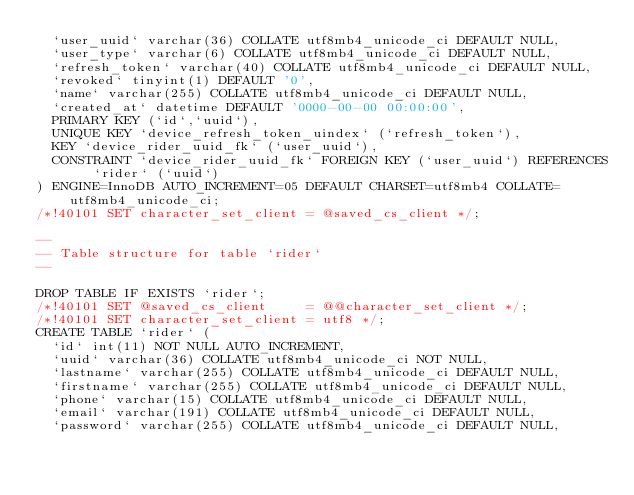Convert code to text. <code><loc_0><loc_0><loc_500><loc_500><_SQL_>  `user_uuid` varchar(36) COLLATE utf8mb4_unicode_ci DEFAULT NULL,
  `user_type` varchar(6) COLLATE utf8mb4_unicode_ci DEFAULT NULL,
  `refresh_token` varchar(40) COLLATE utf8mb4_unicode_ci DEFAULT NULL,
  `revoked` tinyint(1) DEFAULT '0',
  `name` varchar(255) COLLATE utf8mb4_unicode_ci DEFAULT NULL,
  `created_at` datetime DEFAULT '0000-00-00 00:00:00',
  PRIMARY KEY (`id`,`uuid`),
  UNIQUE KEY `device_refresh_token_uindex` (`refresh_token`),
  KEY `device_rider_uuid_fk` (`user_uuid`),
  CONSTRAINT `device_rider_uuid_fk` FOREIGN KEY (`user_uuid`) REFERENCES `rider` (`uuid`)
) ENGINE=InnoDB AUTO_INCREMENT=05 DEFAULT CHARSET=utf8mb4 COLLATE=utf8mb4_unicode_ci;
/*!40101 SET character_set_client = @saved_cs_client */;

--
-- Table structure for table `rider`
--

DROP TABLE IF EXISTS `rider`;
/*!40101 SET @saved_cs_client     = @@character_set_client */;
/*!40101 SET character_set_client = utf8 */;
CREATE TABLE `rider` (
  `id` int(11) NOT NULL AUTO_INCREMENT,
  `uuid` varchar(36) COLLATE utf8mb4_unicode_ci NOT NULL,
  `lastname` varchar(255) COLLATE utf8mb4_unicode_ci DEFAULT NULL,
  `firstname` varchar(255) COLLATE utf8mb4_unicode_ci DEFAULT NULL,
  `phone` varchar(15) COLLATE utf8mb4_unicode_ci DEFAULT NULL,
  `email` varchar(191) COLLATE utf8mb4_unicode_ci DEFAULT NULL,
  `password` varchar(255) COLLATE utf8mb4_unicode_ci DEFAULT NULL,</code> 